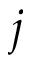<formula> <loc_0><loc_0><loc_500><loc_500>j</formula> 